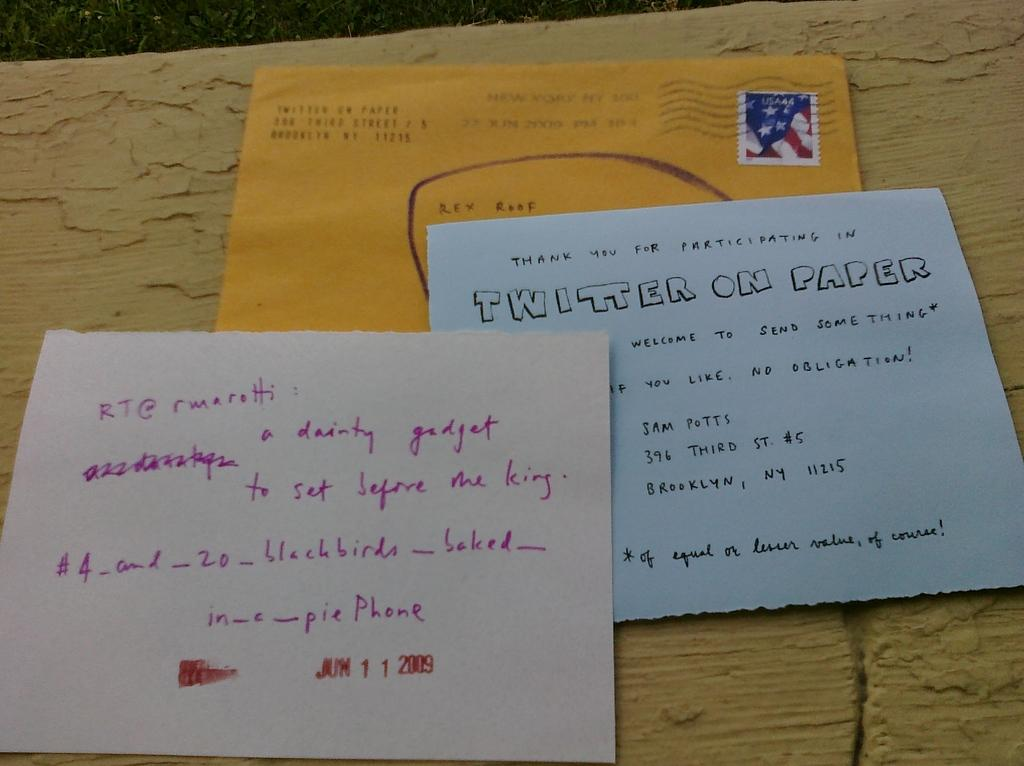<image>
Give a short and clear explanation of the subsequent image. three letters on yellow, blue, or white paper, one of them reading "twitter on paper" 